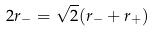Convert formula to latex. <formula><loc_0><loc_0><loc_500><loc_500>2 r _ { - } = \sqrt { 2 } ( r _ { - } + r _ { + } )</formula> 